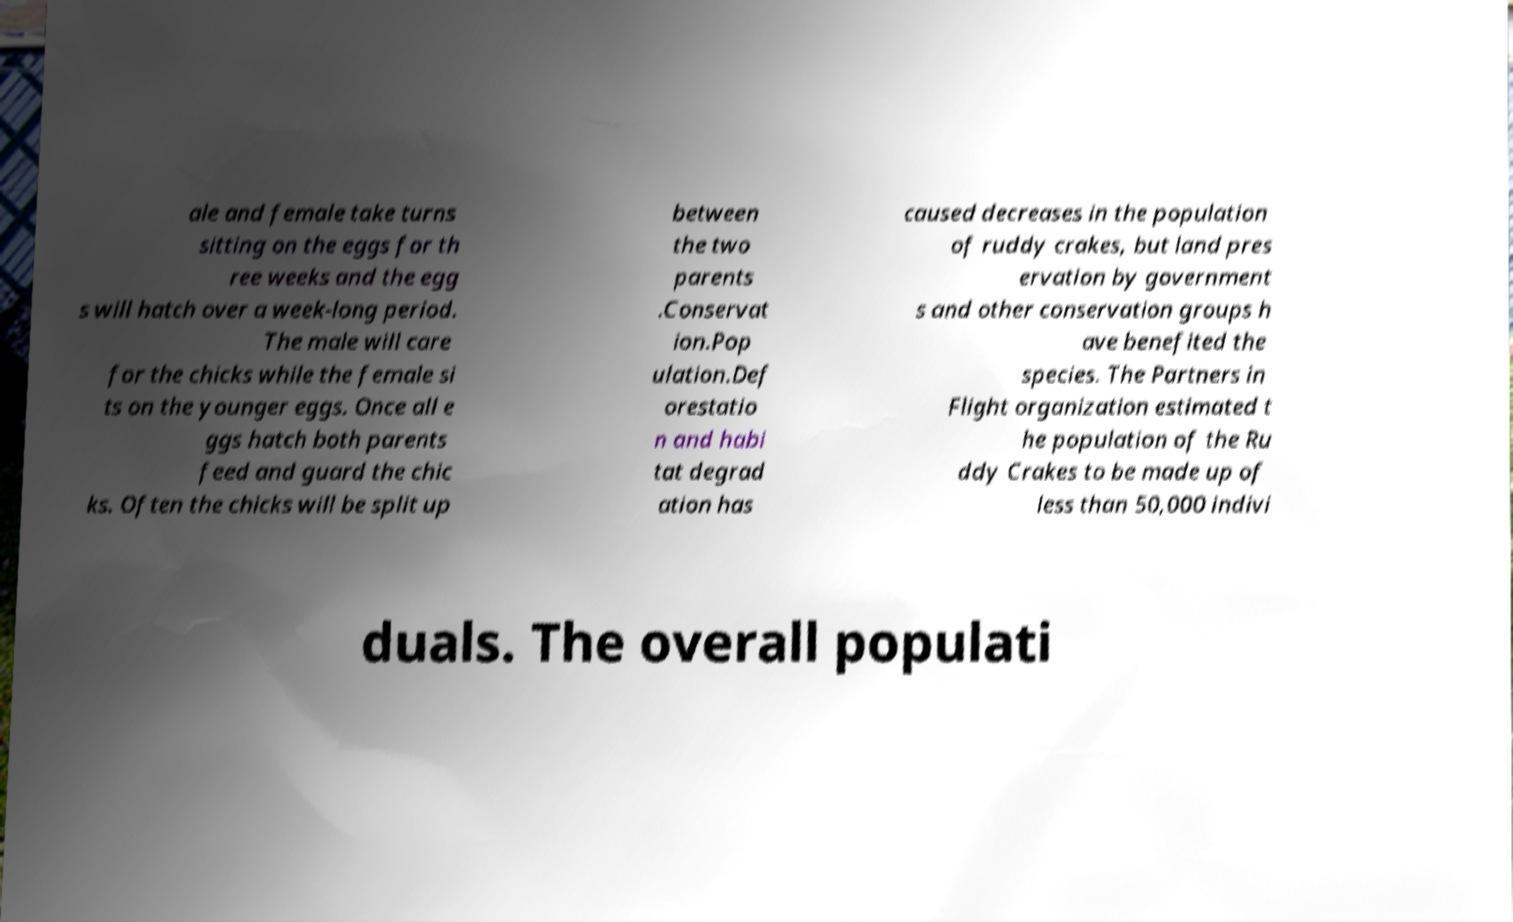Please identify and transcribe the text found in this image. ale and female take turns sitting on the eggs for th ree weeks and the egg s will hatch over a week-long period. The male will care for the chicks while the female si ts on the younger eggs. Once all e ggs hatch both parents feed and guard the chic ks. Often the chicks will be split up between the two parents .Conservat ion.Pop ulation.Def orestatio n and habi tat degrad ation has caused decreases in the population of ruddy crakes, but land pres ervation by government s and other conservation groups h ave benefited the species. The Partners in Flight organization estimated t he population of the Ru ddy Crakes to be made up of less than 50,000 indivi duals. The overall populati 